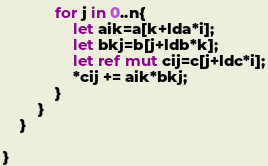Convert code to text. <code><loc_0><loc_0><loc_500><loc_500><_Rust_>            for j in 0..n{
                let aik=a[k+lda*i];
                let bkj=b[j+ldb*k];
                let ref mut cij=c[j+ldc*i];
                *cij += aik*bkj;
            }
        }
    }

}
</code> 